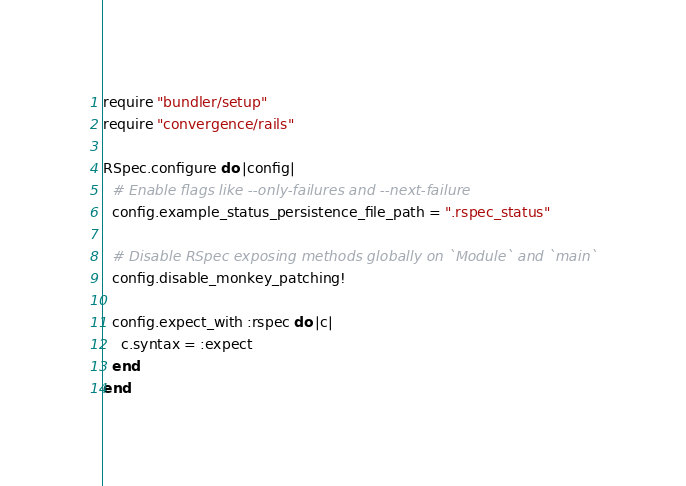<code> <loc_0><loc_0><loc_500><loc_500><_Ruby_>require "bundler/setup"
require "convergence/rails"

RSpec.configure do |config|
  # Enable flags like --only-failures and --next-failure
  config.example_status_persistence_file_path = ".rspec_status"

  # Disable RSpec exposing methods globally on `Module` and `main`
  config.disable_monkey_patching!

  config.expect_with :rspec do |c|
    c.syntax = :expect
  end
end
</code> 